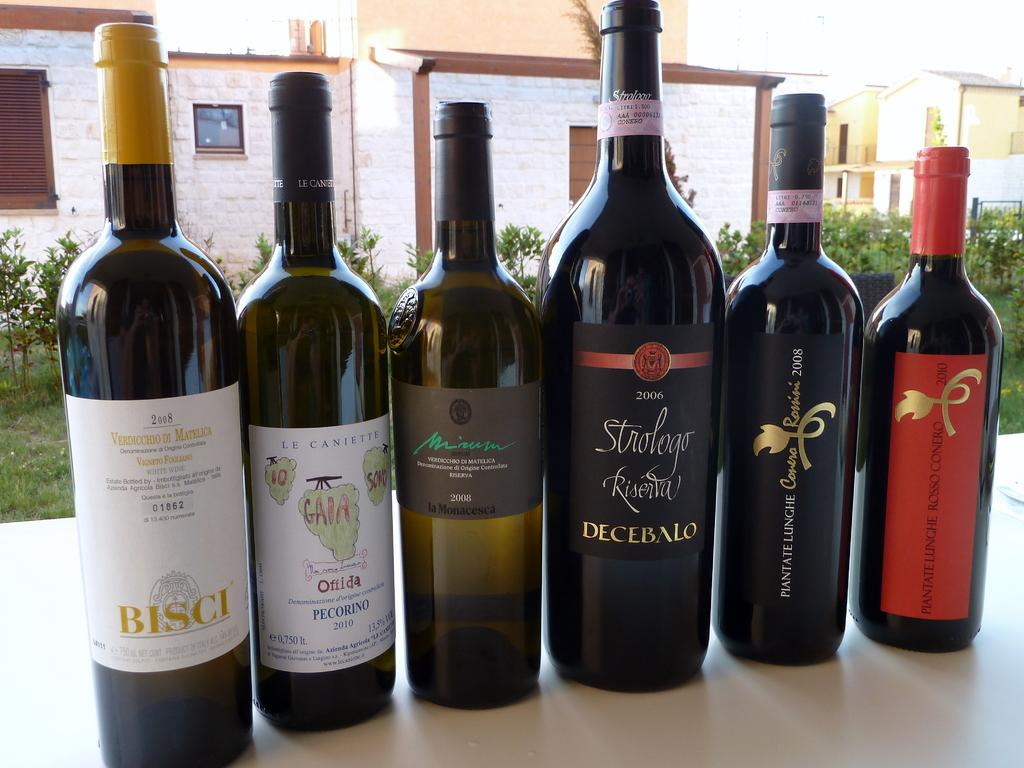<image>
Present a compact description of the photo's key features. several bottles of wine including a 2006 strologo are sitting on a table 